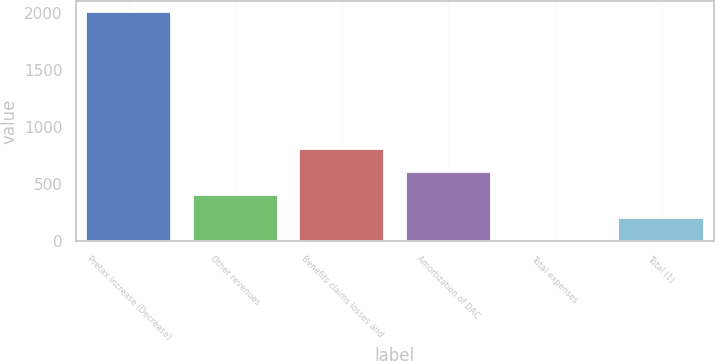<chart> <loc_0><loc_0><loc_500><loc_500><bar_chart><fcel>Pretax Increase (Decrease)<fcel>Other revenues<fcel>Benefits claims losses and<fcel>Amortization of DAC<fcel>Total expenses<fcel>Total (1)<nl><fcel>2011<fcel>403.8<fcel>805.6<fcel>604.7<fcel>2<fcel>202.9<nl></chart> 